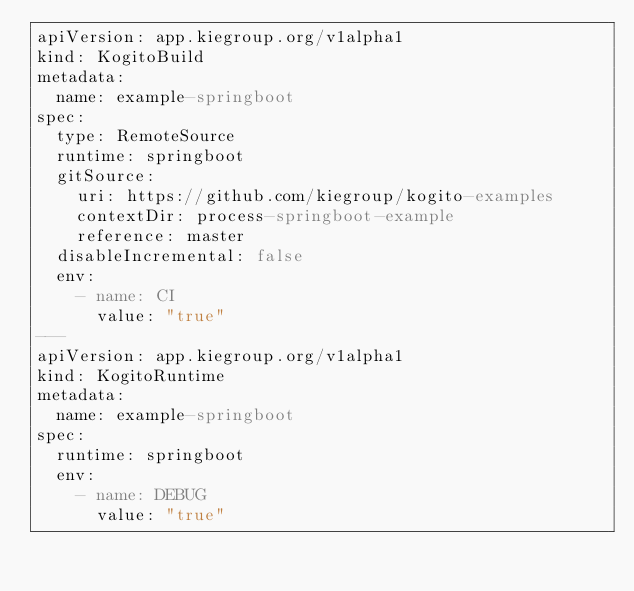Convert code to text. <code><loc_0><loc_0><loc_500><loc_500><_YAML_>apiVersion: app.kiegroup.org/v1alpha1
kind: KogitoBuild
metadata:
  name: example-springboot
spec:
  type: RemoteSource
  runtime: springboot
  gitSource:
    uri: https://github.com/kiegroup/kogito-examples
    contextDir: process-springboot-example
    reference: master
  disableIncremental: false
  env:
    - name: CI
      value: "true"
---
apiVersion: app.kiegroup.org/v1alpha1
kind: KogitoRuntime
metadata:
  name: example-springboot
spec:
  runtime: springboot
  env:
    - name: DEBUG
      value: "true"</code> 